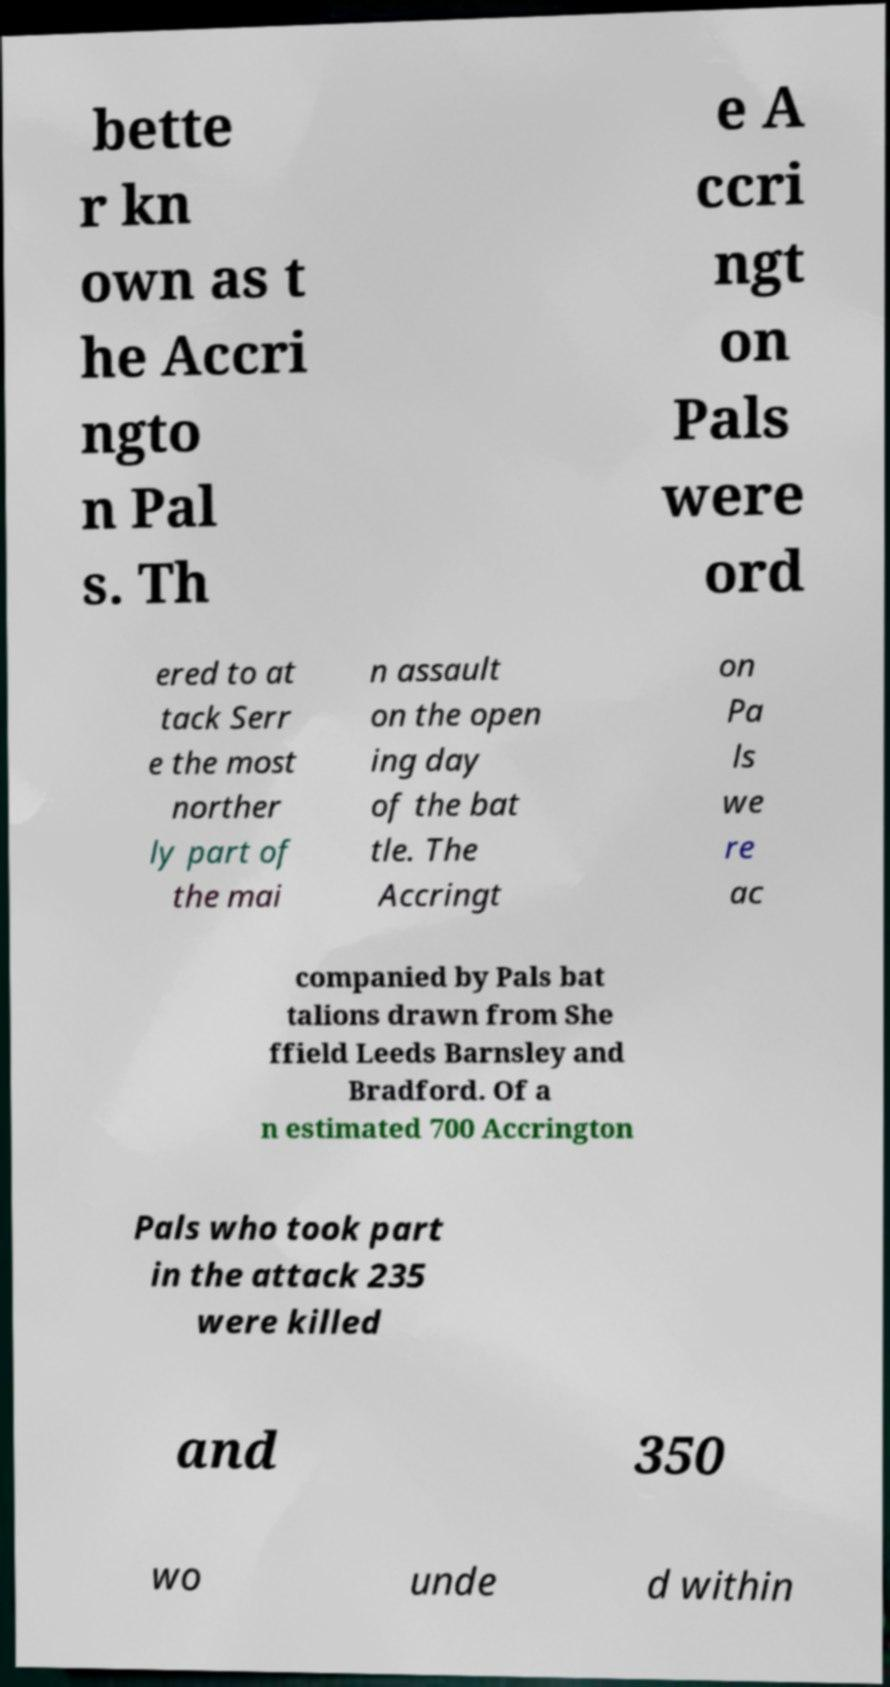There's text embedded in this image that I need extracted. Can you transcribe it verbatim? bette r kn own as t he Accri ngto n Pal s. Th e A ccri ngt on Pals were ord ered to at tack Serr e the most norther ly part of the mai n assault on the open ing day of the bat tle. The Accringt on Pa ls we re ac companied by Pals bat talions drawn from She ffield Leeds Barnsley and Bradford. Of a n estimated 700 Accrington Pals who took part in the attack 235 were killed and 350 wo unde d within 